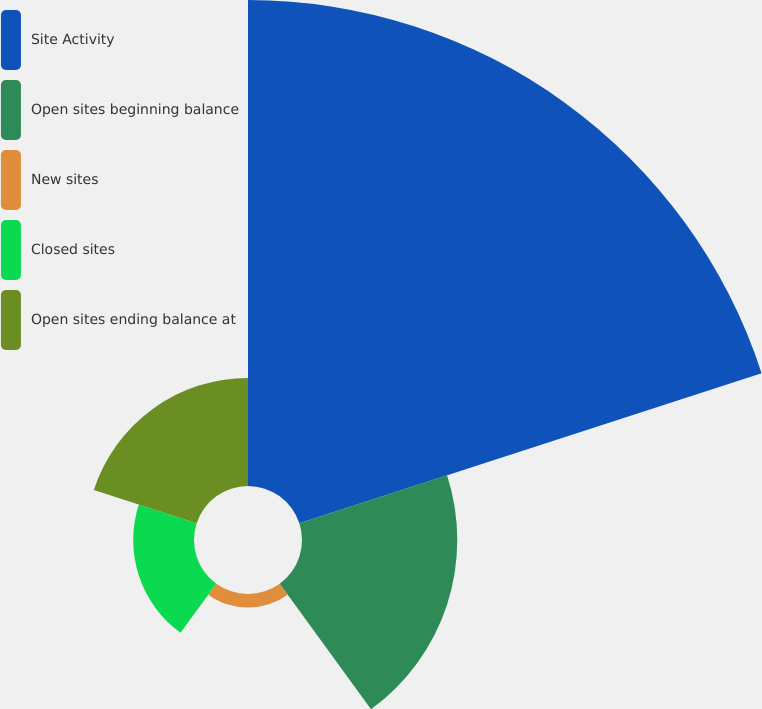<chart> <loc_0><loc_0><loc_500><loc_500><pie_chart><fcel>Site Activity<fcel>Open sites beginning balance<fcel>New sites<fcel>Closed sites<fcel>Open sites ending balance at<nl><fcel>59.0%<fcel>18.85%<fcel>1.65%<fcel>7.38%<fcel>13.12%<nl></chart> 